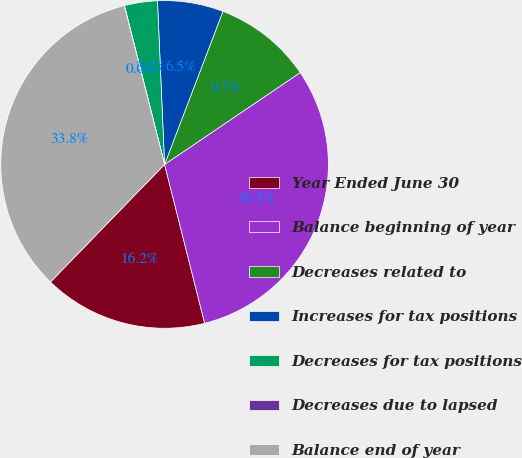<chart> <loc_0><loc_0><loc_500><loc_500><pie_chart><fcel>Year Ended June 30<fcel>Balance beginning of year<fcel>Decreases related to<fcel>Increases for tax positions<fcel>Decreases for tax positions<fcel>Decreases due to lapsed<fcel>Balance end of year<nl><fcel>16.2%<fcel>30.54%<fcel>9.73%<fcel>6.49%<fcel>3.25%<fcel>0.02%<fcel>33.78%<nl></chart> 